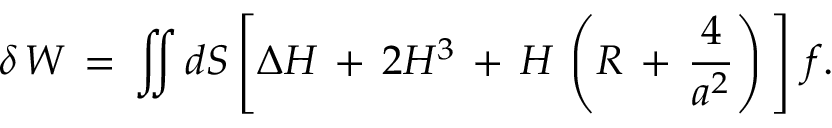Convert formula to latex. <formula><loc_0><loc_0><loc_500><loc_500>\delta \, W \, = \, \int \, \int d S \left [ \Delta H \, + \, 2 H ^ { 3 } \, + \, H \, \left ( R \, + \, \frac { 4 } { a ^ { 2 } } \right ) \, \right ] \, f .</formula> 